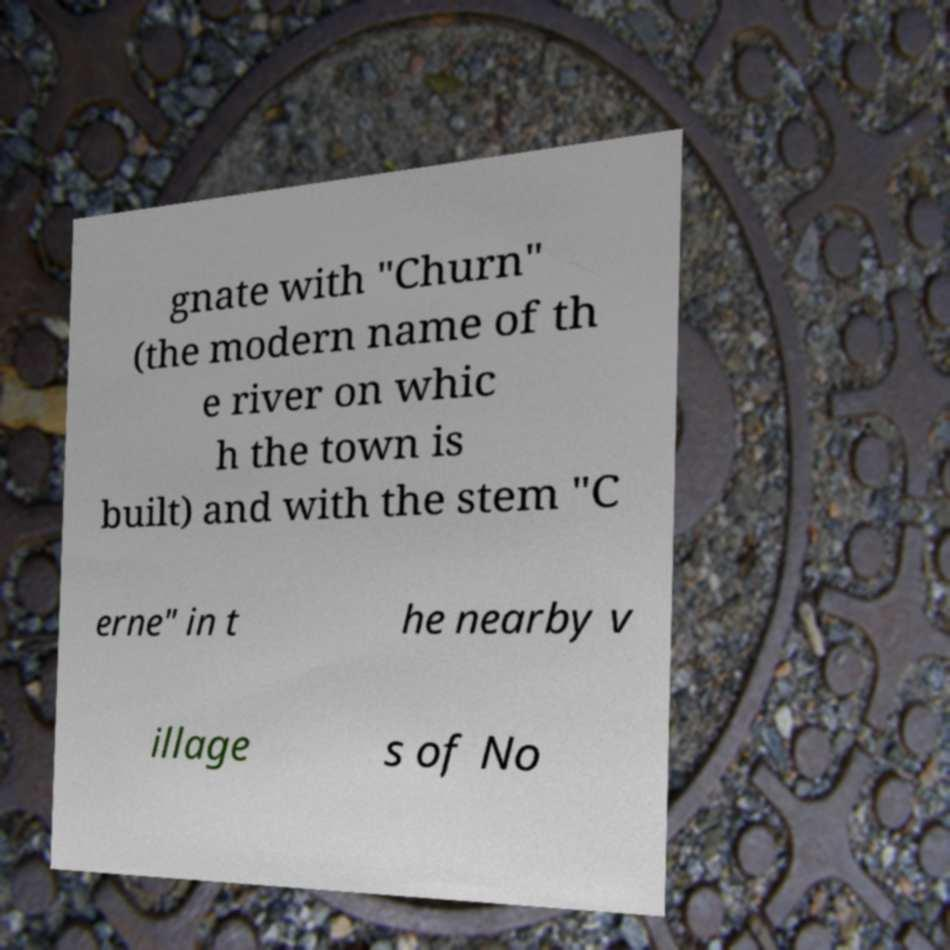Please read and relay the text visible in this image. What does it say? gnate with "Churn" (the modern name of th e river on whic h the town is built) and with the stem "C erne" in t he nearby v illage s of No 